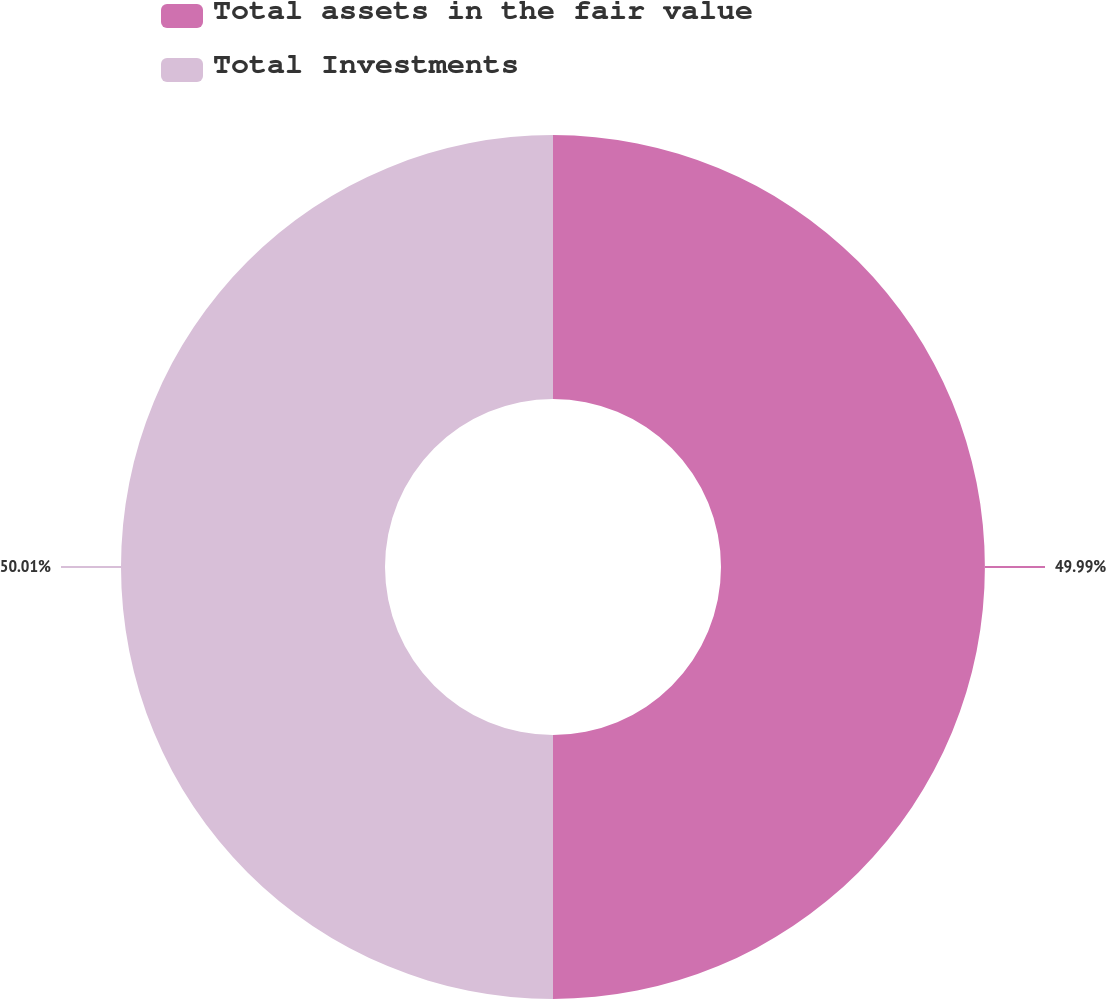Convert chart. <chart><loc_0><loc_0><loc_500><loc_500><pie_chart><fcel>Total assets in the fair value<fcel>Total Investments<nl><fcel>49.99%<fcel>50.01%<nl></chart> 